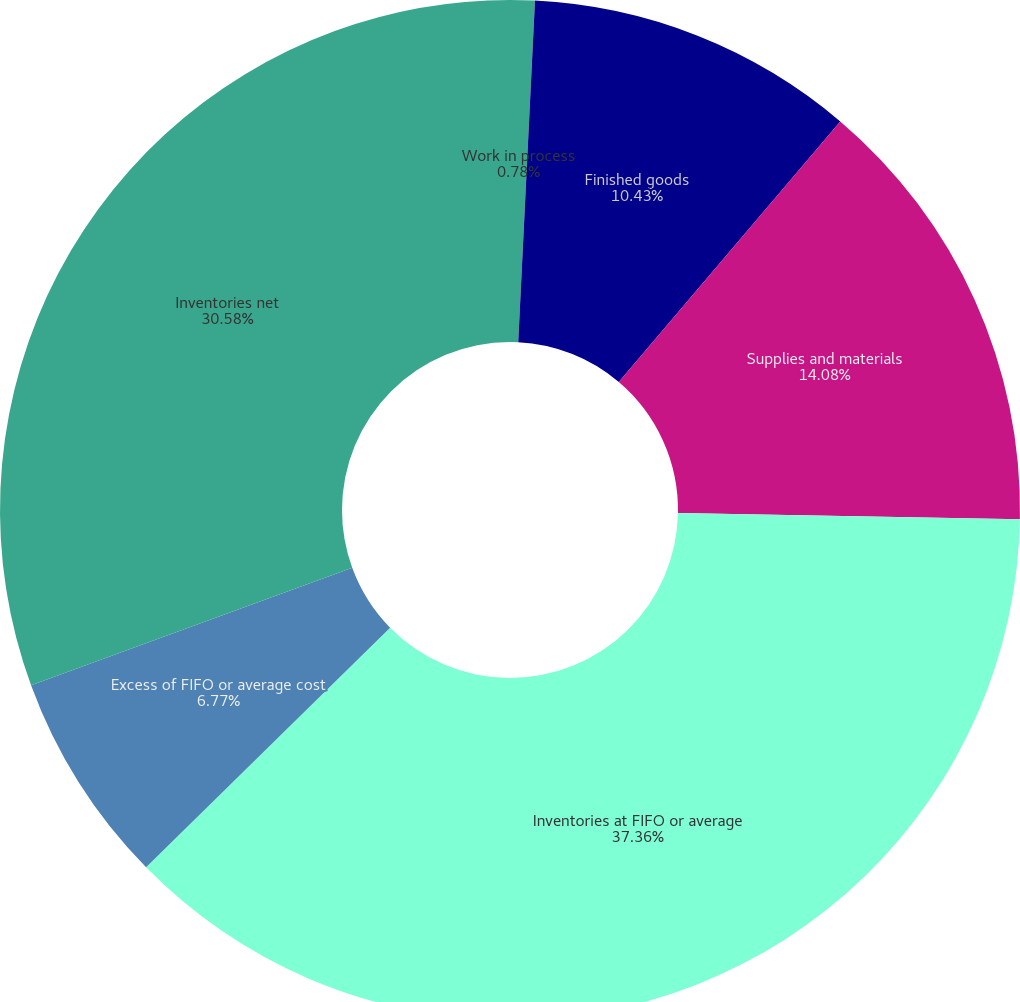<chart> <loc_0><loc_0><loc_500><loc_500><pie_chart><fcel>Work in process<fcel>Finished goods<fcel>Supplies and materials<fcel>Inventories at FIFO or average<fcel>Excess of FIFO or average cost<fcel>Inventories net<nl><fcel>0.78%<fcel>10.43%<fcel>14.08%<fcel>37.35%<fcel>6.77%<fcel>30.58%<nl></chart> 